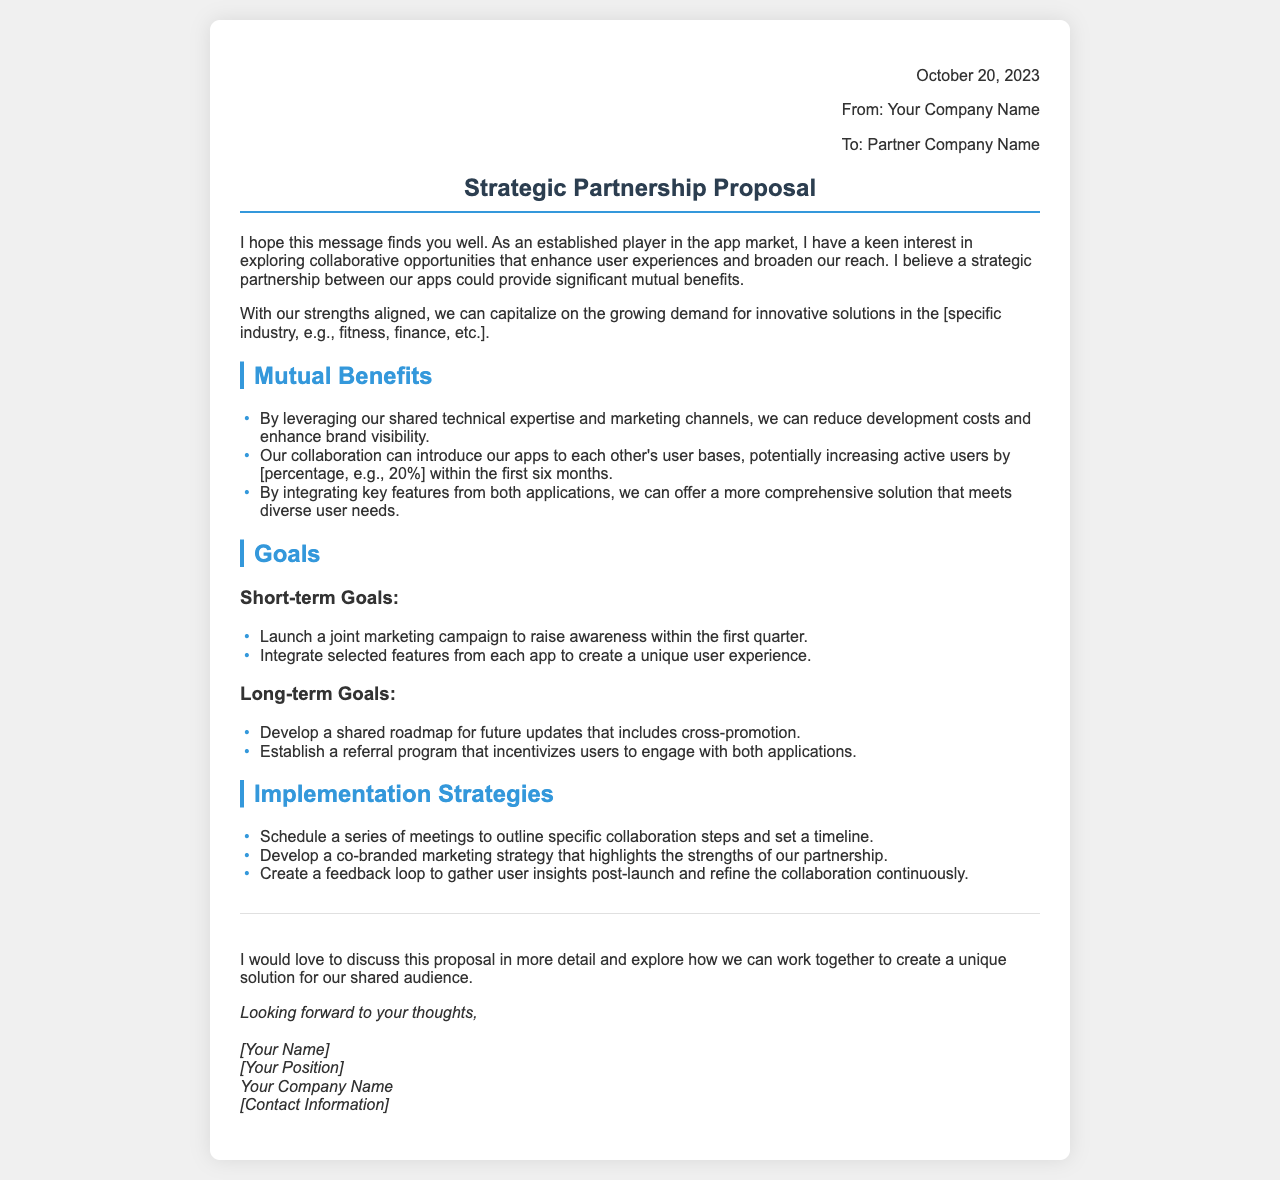what is the date of the proposal? The date of the proposal is stated at the beginning of the document.
Answer: October 20, 2023 what is the proposal's main topic? The main topic of the proposal is indicated in the subject line.
Answer: Strategic Partnership Proposal who is the proposal from? The sender's information is included in the header of the document.
Answer: Your Company Name how much is the expected increase in active users within the first six months? This information is provided in the section discussing mutual benefits.
Answer: 20% what is one short-term goal mentioned in the document? The document outlines specific short-term goals under the Goals section.
Answer: Launch a joint marketing campaign what is a long-term goal stated in the proposal? The proposal specifies future goals in the Goals section.
Answer: Develop a shared roadmap for future updates what is one of the implementation strategies listed? The implementation strategies are highlighted in a specific section.
Answer: Schedule a series of meetings what kind of feedback process is proposed after the launch? The document mentions a specific method for gathering user insights post-launch.
Answer: Create a feedback loop who is the proposal addressed to? The recipient's information is included in the header of the document.
Answer: Partner Company Name 